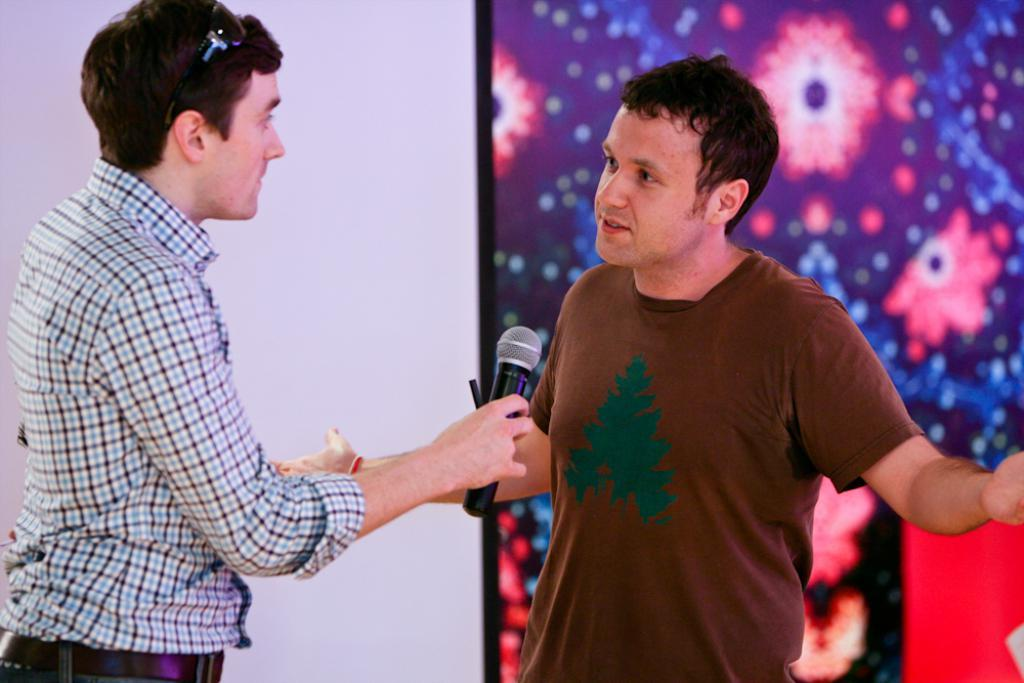How many people are in the image? There are two persons in the image. What is one of the persons holding? One of the persons is holding a mic. Can you describe the appearance of the person holding the mic? The person holding the mic is wearing goggles. What type of fork can be seen in the image? There is no fork present in the image. Is the hill visible in the image? There is no hill present in the image. 